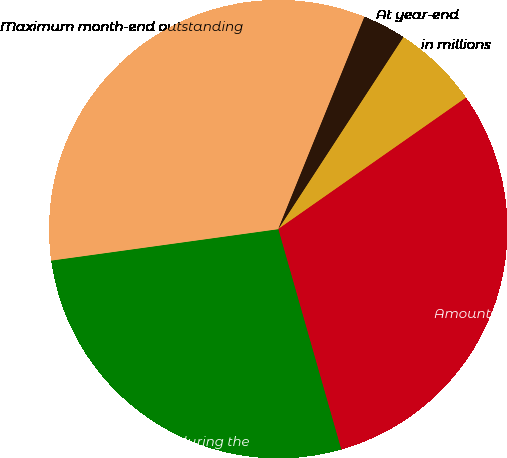Convert chart. <chart><loc_0><loc_0><loc_500><loc_500><pie_chart><fcel>in millions<fcel>Amounts outstanding at<fcel>Average outstanding during the<fcel>Maximum month-end outstanding<fcel>During the year<fcel>At year-end<nl><fcel>6.09%<fcel>30.29%<fcel>27.24%<fcel>33.33%<fcel>3.05%<fcel>0.0%<nl></chart> 